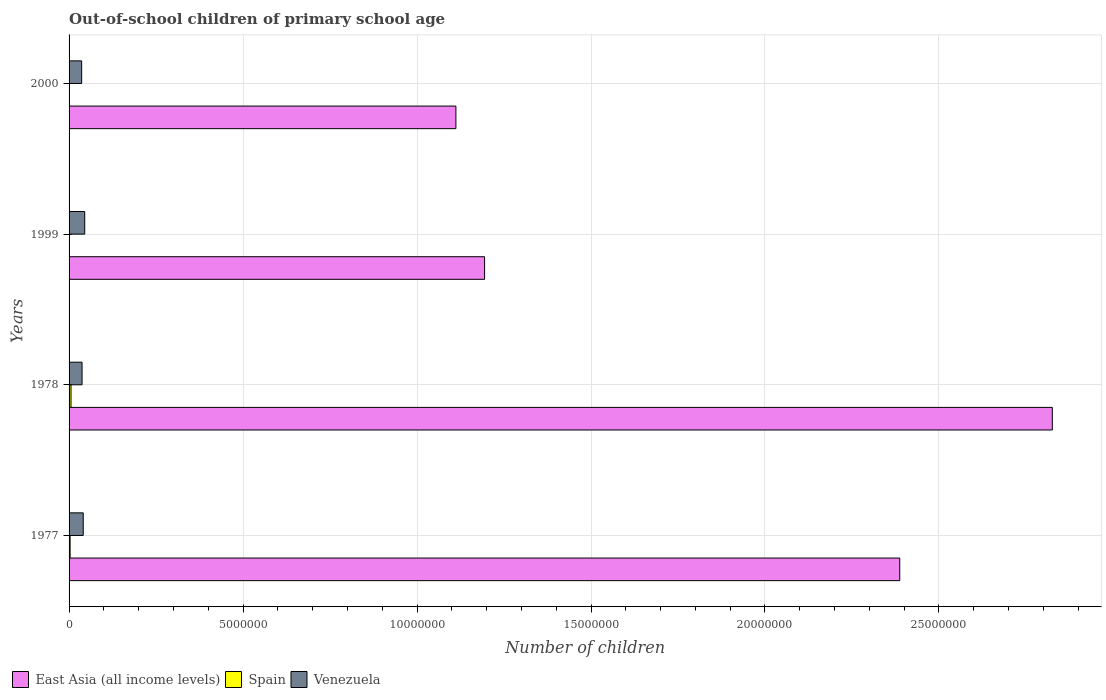How many different coloured bars are there?
Offer a terse response. 3. Are the number of bars per tick equal to the number of legend labels?
Keep it short and to the point. Yes. Are the number of bars on each tick of the Y-axis equal?
Your answer should be very brief. Yes. How many bars are there on the 4th tick from the bottom?
Your response must be concise. 3. In how many cases, is the number of bars for a given year not equal to the number of legend labels?
Your response must be concise. 0. What is the number of out-of-school children in Venezuela in 1999?
Give a very brief answer. 4.50e+05. Across all years, what is the maximum number of out-of-school children in Spain?
Your answer should be very brief. 5.59e+04. Across all years, what is the minimum number of out-of-school children in East Asia (all income levels)?
Your answer should be compact. 1.11e+07. In which year was the number of out-of-school children in Venezuela minimum?
Give a very brief answer. 2000. What is the total number of out-of-school children in East Asia (all income levels) in the graph?
Provide a short and direct response. 7.52e+07. What is the difference between the number of out-of-school children in East Asia (all income levels) in 1978 and that in 2000?
Keep it short and to the point. 1.71e+07. What is the difference between the number of out-of-school children in Spain in 1978 and the number of out-of-school children in Venezuela in 1977?
Your answer should be very brief. -3.51e+05. What is the average number of out-of-school children in Venezuela per year?
Make the answer very short. 3.98e+05. In the year 2000, what is the difference between the number of out-of-school children in Spain and number of out-of-school children in Venezuela?
Give a very brief answer. -3.60e+05. In how many years, is the number of out-of-school children in East Asia (all income levels) greater than 20000000 ?
Give a very brief answer. 2. What is the ratio of the number of out-of-school children in Venezuela in 1977 to that in 1978?
Your answer should be compact. 1.09. Is the number of out-of-school children in East Asia (all income levels) in 1977 less than that in 2000?
Provide a succinct answer. No. Is the difference between the number of out-of-school children in Spain in 1977 and 1978 greater than the difference between the number of out-of-school children in Venezuela in 1977 and 1978?
Provide a succinct answer. No. What is the difference between the highest and the second highest number of out-of-school children in East Asia (all income levels)?
Offer a terse response. 4.39e+06. What is the difference between the highest and the lowest number of out-of-school children in East Asia (all income levels)?
Make the answer very short. 1.71e+07. Is the sum of the number of out-of-school children in East Asia (all income levels) in 1999 and 2000 greater than the maximum number of out-of-school children in Venezuela across all years?
Keep it short and to the point. Yes. What does the 1st bar from the top in 1978 represents?
Offer a very short reply. Venezuela. What does the 3rd bar from the bottom in 1977 represents?
Offer a very short reply. Venezuela. Is it the case that in every year, the sum of the number of out-of-school children in Spain and number of out-of-school children in East Asia (all income levels) is greater than the number of out-of-school children in Venezuela?
Your response must be concise. Yes. Does the graph contain grids?
Your answer should be compact. Yes. Where does the legend appear in the graph?
Your answer should be compact. Bottom left. How are the legend labels stacked?
Make the answer very short. Horizontal. What is the title of the graph?
Ensure brevity in your answer.  Out-of-school children of primary school age. What is the label or title of the X-axis?
Offer a very short reply. Number of children. What is the label or title of the Y-axis?
Keep it short and to the point. Years. What is the Number of children in East Asia (all income levels) in 1977?
Ensure brevity in your answer.  2.39e+07. What is the Number of children in Spain in 1977?
Provide a succinct answer. 2.98e+04. What is the Number of children in Venezuela in 1977?
Your answer should be very brief. 4.07e+05. What is the Number of children in East Asia (all income levels) in 1978?
Provide a short and direct response. 2.83e+07. What is the Number of children of Spain in 1978?
Your response must be concise. 5.59e+04. What is the Number of children in Venezuela in 1978?
Provide a succinct answer. 3.73e+05. What is the Number of children in East Asia (all income levels) in 1999?
Ensure brevity in your answer.  1.19e+07. What is the Number of children of Spain in 1999?
Your answer should be compact. 7510. What is the Number of children of Venezuela in 1999?
Your answer should be compact. 4.50e+05. What is the Number of children of East Asia (all income levels) in 2000?
Your response must be concise. 1.11e+07. What is the Number of children in Spain in 2000?
Give a very brief answer. 1405. What is the Number of children in Venezuela in 2000?
Provide a succinct answer. 3.62e+05. Across all years, what is the maximum Number of children of East Asia (all income levels)?
Give a very brief answer. 2.83e+07. Across all years, what is the maximum Number of children in Spain?
Keep it short and to the point. 5.59e+04. Across all years, what is the maximum Number of children in Venezuela?
Provide a short and direct response. 4.50e+05. Across all years, what is the minimum Number of children in East Asia (all income levels)?
Your response must be concise. 1.11e+07. Across all years, what is the minimum Number of children of Spain?
Offer a terse response. 1405. Across all years, what is the minimum Number of children in Venezuela?
Offer a very short reply. 3.62e+05. What is the total Number of children in East Asia (all income levels) in the graph?
Your response must be concise. 7.52e+07. What is the total Number of children of Spain in the graph?
Provide a short and direct response. 9.46e+04. What is the total Number of children of Venezuela in the graph?
Provide a short and direct response. 1.59e+06. What is the difference between the Number of children in East Asia (all income levels) in 1977 and that in 1978?
Keep it short and to the point. -4.39e+06. What is the difference between the Number of children in Spain in 1977 and that in 1978?
Offer a terse response. -2.61e+04. What is the difference between the Number of children of Venezuela in 1977 and that in 1978?
Your answer should be compact. 3.37e+04. What is the difference between the Number of children in East Asia (all income levels) in 1977 and that in 1999?
Offer a very short reply. 1.19e+07. What is the difference between the Number of children of Spain in 1977 and that in 1999?
Ensure brevity in your answer.  2.23e+04. What is the difference between the Number of children of Venezuela in 1977 and that in 1999?
Your answer should be very brief. -4.27e+04. What is the difference between the Number of children of East Asia (all income levels) in 1977 and that in 2000?
Offer a very short reply. 1.28e+07. What is the difference between the Number of children of Spain in 1977 and that in 2000?
Offer a very short reply. 2.84e+04. What is the difference between the Number of children in Venezuela in 1977 and that in 2000?
Ensure brevity in your answer.  4.53e+04. What is the difference between the Number of children in East Asia (all income levels) in 1978 and that in 1999?
Make the answer very short. 1.63e+07. What is the difference between the Number of children in Spain in 1978 and that in 1999?
Give a very brief answer. 4.84e+04. What is the difference between the Number of children in Venezuela in 1978 and that in 1999?
Give a very brief answer. -7.64e+04. What is the difference between the Number of children of East Asia (all income levels) in 1978 and that in 2000?
Provide a short and direct response. 1.71e+07. What is the difference between the Number of children of Spain in 1978 and that in 2000?
Give a very brief answer. 5.45e+04. What is the difference between the Number of children in Venezuela in 1978 and that in 2000?
Your answer should be compact. 1.16e+04. What is the difference between the Number of children in East Asia (all income levels) in 1999 and that in 2000?
Make the answer very short. 8.25e+05. What is the difference between the Number of children in Spain in 1999 and that in 2000?
Your answer should be very brief. 6105. What is the difference between the Number of children in Venezuela in 1999 and that in 2000?
Provide a succinct answer. 8.80e+04. What is the difference between the Number of children in East Asia (all income levels) in 1977 and the Number of children in Spain in 1978?
Your answer should be very brief. 2.38e+07. What is the difference between the Number of children in East Asia (all income levels) in 1977 and the Number of children in Venezuela in 1978?
Ensure brevity in your answer.  2.35e+07. What is the difference between the Number of children of Spain in 1977 and the Number of children of Venezuela in 1978?
Make the answer very short. -3.43e+05. What is the difference between the Number of children in East Asia (all income levels) in 1977 and the Number of children in Spain in 1999?
Give a very brief answer. 2.39e+07. What is the difference between the Number of children in East Asia (all income levels) in 1977 and the Number of children in Venezuela in 1999?
Give a very brief answer. 2.34e+07. What is the difference between the Number of children in Spain in 1977 and the Number of children in Venezuela in 1999?
Offer a terse response. -4.20e+05. What is the difference between the Number of children in East Asia (all income levels) in 1977 and the Number of children in Spain in 2000?
Offer a terse response. 2.39e+07. What is the difference between the Number of children of East Asia (all income levels) in 1977 and the Number of children of Venezuela in 2000?
Provide a succinct answer. 2.35e+07. What is the difference between the Number of children of Spain in 1977 and the Number of children of Venezuela in 2000?
Provide a succinct answer. -3.32e+05. What is the difference between the Number of children in East Asia (all income levels) in 1978 and the Number of children in Spain in 1999?
Give a very brief answer. 2.83e+07. What is the difference between the Number of children in East Asia (all income levels) in 1978 and the Number of children in Venezuela in 1999?
Your response must be concise. 2.78e+07. What is the difference between the Number of children of Spain in 1978 and the Number of children of Venezuela in 1999?
Your answer should be compact. -3.94e+05. What is the difference between the Number of children of East Asia (all income levels) in 1978 and the Number of children of Spain in 2000?
Your answer should be compact. 2.83e+07. What is the difference between the Number of children of East Asia (all income levels) in 1978 and the Number of children of Venezuela in 2000?
Ensure brevity in your answer.  2.79e+07. What is the difference between the Number of children in Spain in 1978 and the Number of children in Venezuela in 2000?
Your answer should be compact. -3.06e+05. What is the difference between the Number of children in East Asia (all income levels) in 1999 and the Number of children in Spain in 2000?
Offer a very short reply. 1.19e+07. What is the difference between the Number of children in East Asia (all income levels) in 1999 and the Number of children in Venezuela in 2000?
Make the answer very short. 1.16e+07. What is the difference between the Number of children in Spain in 1999 and the Number of children in Venezuela in 2000?
Provide a short and direct response. -3.54e+05. What is the average Number of children of East Asia (all income levels) per year?
Keep it short and to the point. 1.88e+07. What is the average Number of children of Spain per year?
Your answer should be compact. 2.37e+04. What is the average Number of children of Venezuela per year?
Offer a very short reply. 3.98e+05. In the year 1977, what is the difference between the Number of children in East Asia (all income levels) and Number of children in Spain?
Offer a very short reply. 2.38e+07. In the year 1977, what is the difference between the Number of children of East Asia (all income levels) and Number of children of Venezuela?
Your response must be concise. 2.35e+07. In the year 1977, what is the difference between the Number of children in Spain and Number of children in Venezuela?
Make the answer very short. -3.77e+05. In the year 1978, what is the difference between the Number of children of East Asia (all income levels) and Number of children of Spain?
Keep it short and to the point. 2.82e+07. In the year 1978, what is the difference between the Number of children in East Asia (all income levels) and Number of children in Venezuela?
Provide a succinct answer. 2.79e+07. In the year 1978, what is the difference between the Number of children of Spain and Number of children of Venezuela?
Offer a terse response. -3.17e+05. In the year 1999, what is the difference between the Number of children in East Asia (all income levels) and Number of children in Spain?
Provide a short and direct response. 1.19e+07. In the year 1999, what is the difference between the Number of children in East Asia (all income levels) and Number of children in Venezuela?
Your answer should be very brief. 1.15e+07. In the year 1999, what is the difference between the Number of children in Spain and Number of children in Venezuela?
Your answer should be very brief. -4.42e+05. In the year 2000, what is the difference between the Number of children in East Asia (all income levels) and Number of children in Spain?
Offer a very short reply. 1.11e+07. In the year 2000, what is the difference between the Number of children in East Asia (all income levels) and Number of children in Venezuela?
Provide a short and direct response. 1.08e+07. In the year 2000, what is the difference between the Number of children of Spain and Number of children of Venezuela?
Make the answer very short. -3.60e+05. What is the ratio of the Number of children of East Asia (all income levels) in 1977 to that in 1978?
Your answer should be very brief. 0.84. What is the ratio of the Number of children in Spain in 1977 to that in 1978?
Your response must be concise. 0.53. What is the ratio of the Number of children of Venezuela in 1977 to that in 1978?
Ensure brevity in your answer.  1.09. What is the ratio of the Number of children of East Asia (all income levels) in 1977 to that in 1999?
Your answer should be very brief. 2. What is the ratio of the Number of children in Spain in 1977 to that in 1999?
Provide a short and direct response. 3.97. What is the ratio of the Number of children of Venezuela in 1977 to that in 1999?
Your answer should be very brief. 0.9. What is the ratio of the Number of children of East Asia (all income levels) in 1977 to that in 2000?
Provide a succinct answer. 2.15. What is the ratio of the Number of children of Spain in 1977 to that in 2000?
Make the answer very short. 21.21. What is the ratio of the Number of children of Venezuela in 1977 to that in 2000?
Make the answer very short. 1.13. What is the ratio of the Number of children in East Asia (all income levels) in 1978 to that in 1999?
Your response must be concise. 2.37. What is the ratio of the Number of children of Spain in 1978 to that in 1999?
Ensure brevity in your answer.  7.45. What is the ratio of the Number of children of Venezuela in 1978 to that in 1999?
Keep it short and to the point. 0.83. What is the ratio of the Number of children in East Asia (all income levels) in 1978 to that in 2000?
Your answer should be compact. 2.54. What is the ratio of the Number of children in Spain in 1978 to that in 2000?
Your response must be concise. 39.81. What is the ratio of the Number of children of Venezuela in 1978 to that in 2000?
Keep it short and to the point. 1.03. What is the ratio of the Number of children in East Asia (all income levels) in 1999 to that in 2000?
Provide a succinct answer. 1.07. What is the ratio of the Number of children of Spain in 1999 to that in 2000?
Your response must be concise. 5.35. What is the ratio of the Number of children of Venezuela in 1999 to that in 2000?
Your response must be concise. 1.24. What is the difference between the highest and the second highest Number of children in East Asia (all income levels)?
Offer a very short reply. 4.39e+06. What is the difference between the highest and the second highest Number of children in Spain?
Provide a succinct answer. 2.61e+04. What is the difference between the highest and the second highest Number of children of Venezuela?
Offer a very short reply. 4.27e+04. What is the difference between the highest and the lowest Number of children in East Asia (all income levels)?
Keep it short and to the point. 1.71e+07. What is the difference between the highest and the lowest Number of children of Spain?
Your answer should be very brief. 5.45e+04. What is the difference between the highest and the lowest Number of children in Venezuela?
Give a very brief answer. 8.80e+04. 